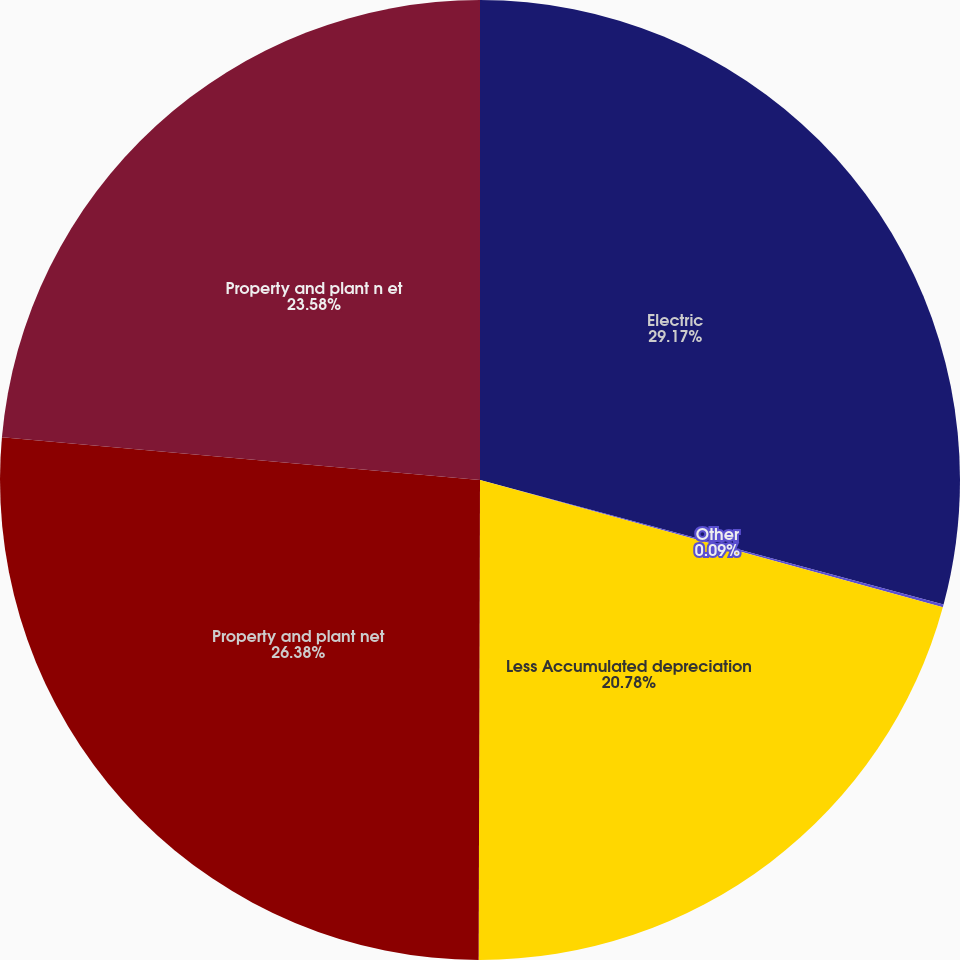Convert chart to OTSL. <chart><loc_0><loc_0><loc_500><loc_500><pie_chart><fcel>Electric<fcel>Other<fcel>Less Accumulated depreciation<fcel>Property and plant net<fcel>Property and plant n et<nl><fcel>29.18%<fcel>0.09%<fcel>20.78%<fcel>26.38%<fcel>23.58%<nl></chart> 